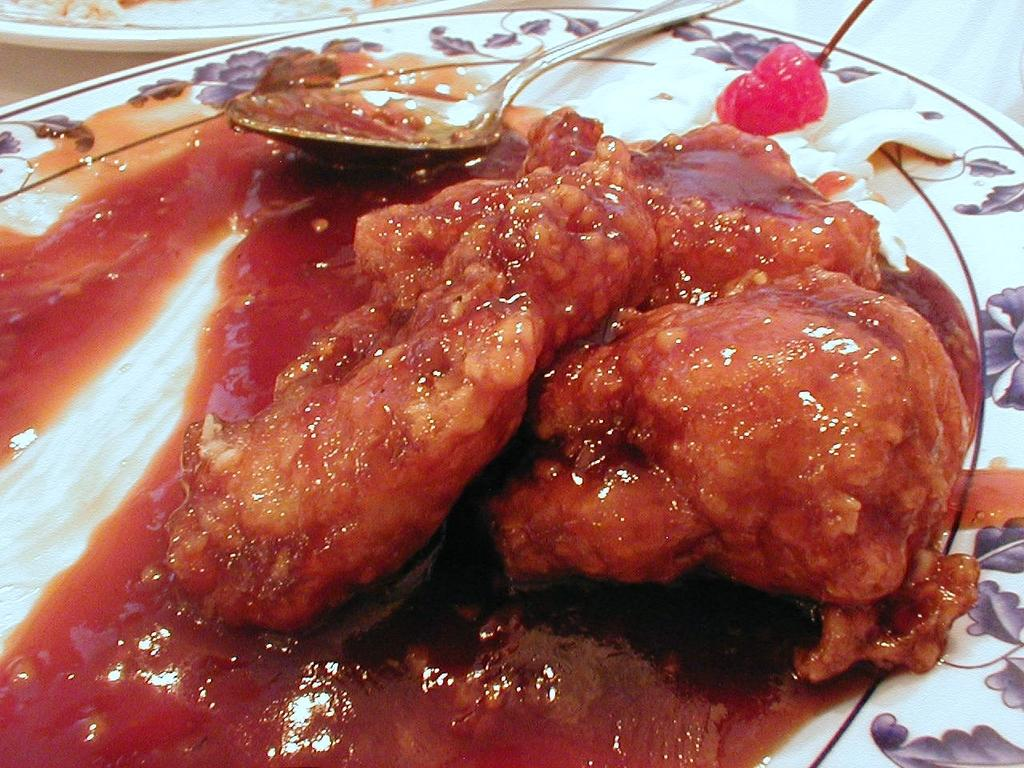What is located at the bottom of the image? There is a plate at the bottom of the image. What is on the plate at the bottom of the image? There are food items on the plate, and there is a spoon on the plate as well. What is located at the top of the image? There is another plate at the top of the image. What type of fowl can be seen in the caption of the image? There is no caption present in the image, and therefore no fowl can be seen in it. 